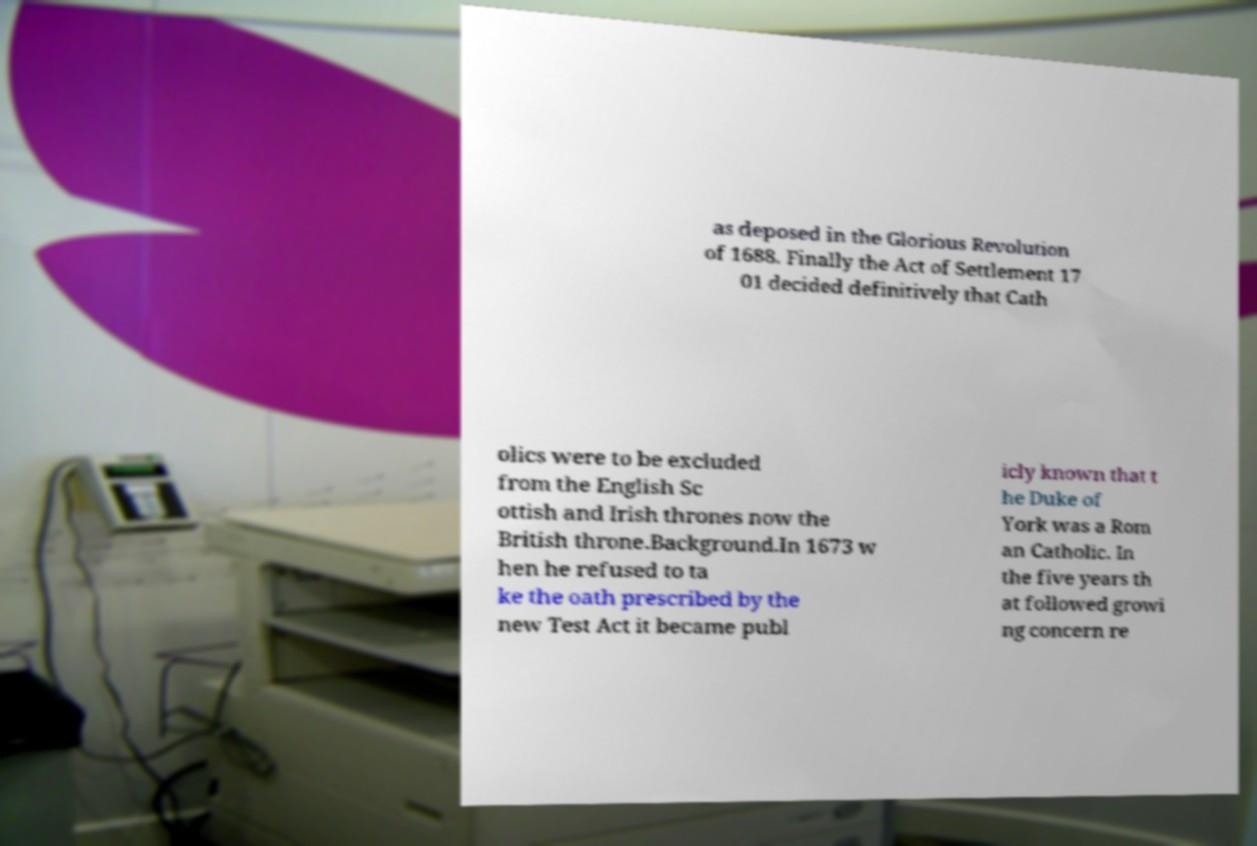Could you extract and type out the text from this image? as deposed in the Glorious Revolution of 1688. Finally the Act of Settlement 17 01 decided definitively that Cath olics were to be excluded from the English Sc ottish and Irish thrones now the British throne.Background.In 1673 w hen he refused to ta ke the oath prescribed by the new Test Act it became publ icly known that t he Duke of York was a Rom an Catholic. In the five years th at followed growi ng concern re 